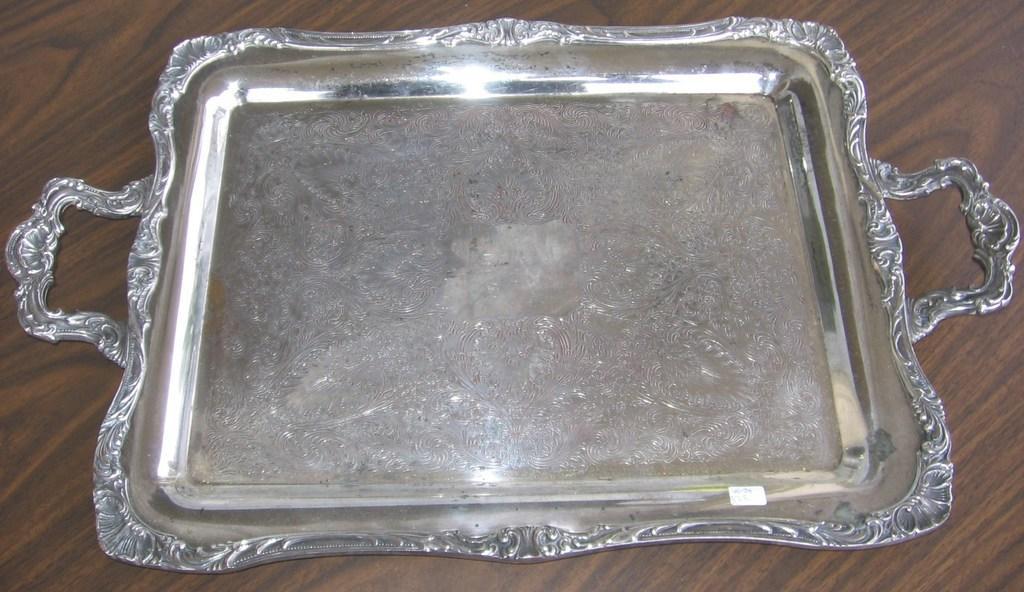How would you summarize this image in a sentence or two? In this image we can see a silver serving tray which is on the table. 